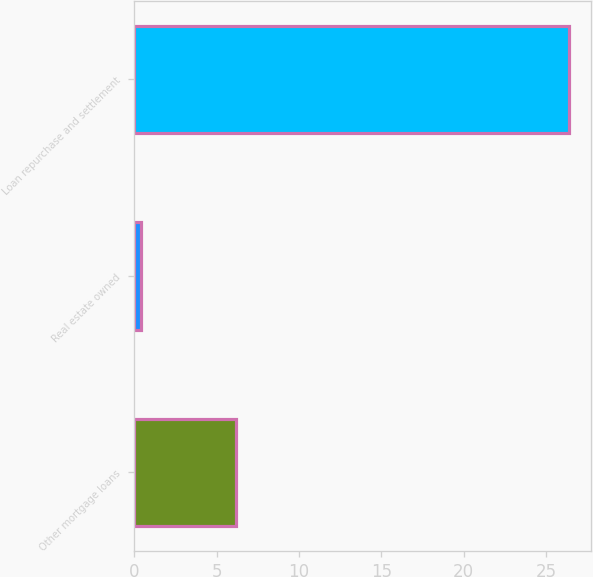<chart> <loc_0><loc_0><loc_500><loc_500><bar_chart><fcel>Other mortgage loans<fcel>Real estate owned<fcel>Loan repurchase and settlement<nl><fcel>6.2<fcel>0.4<fcel>26.4<nl></chart> 